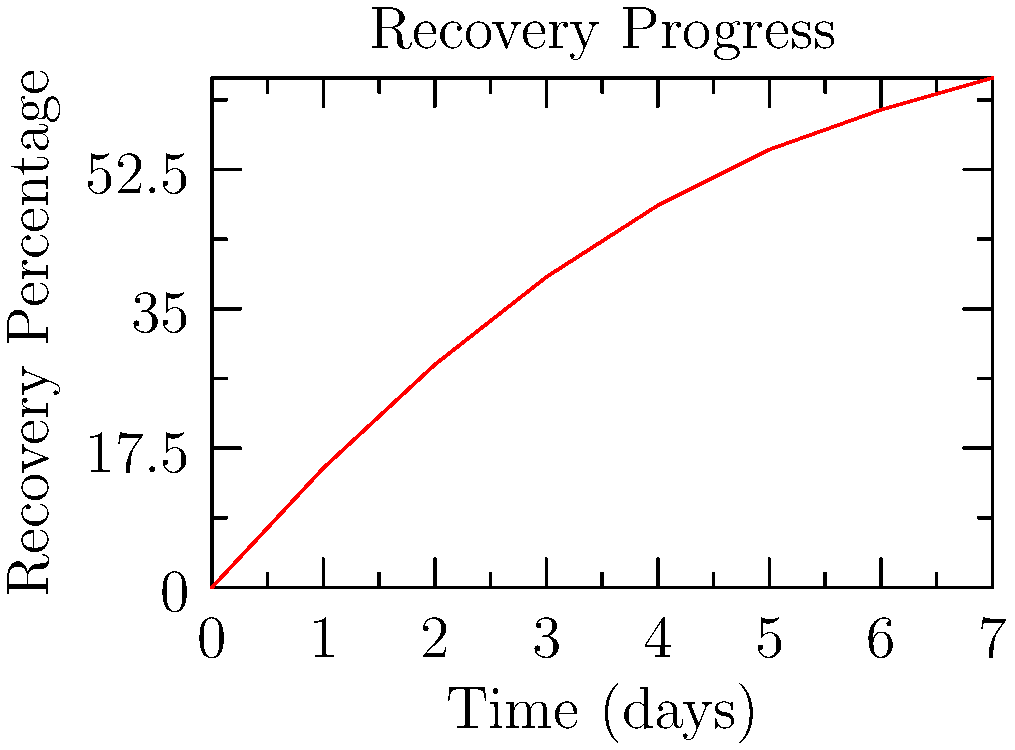The graph shows the recovery progress of patients over time in a resource-limited community clinic. Calculate the average rate of change in recovery percentage between day 2 and day 5. What does this value represent in the context of patient care? To calculate the average rate of change between day 2 and day 5:

1. Identify the points:
   Day 2: (2, 28%)
   Day 5: (5, 55%)

2. Calculate the change in recovery percentage:
   $\Delta y = 55\% - 28\% = 27\%$

3. Calculate the change in time:
   $\Delta x = 5 - 2 = 3$ days

4. Apply the average rate of change formula:
   Average rate of change = $\frac{\Delta y}{\Delta x} = \frac{27\%}{3\text{ days}} = 9\%\text{ per day}$

This value represents the average daily increase in recovery percentage for patients between day 2 and day 5. In the context of patient care, it indicates the speed of recovery during this period, which can help nurses assess the effectiveness of treatments and allocate resources efficiently in a resource-limited setting.
Answer: 9% per day 